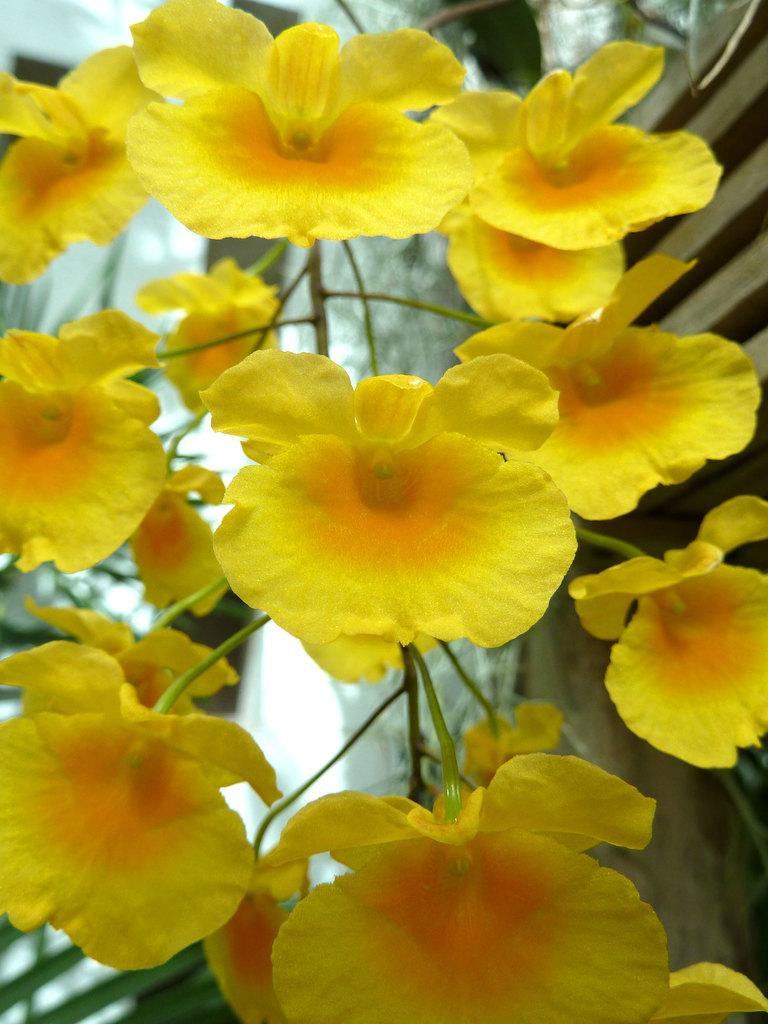What type of flowers can be seen in the image? There are yellow color flowers in the image. What type of ship is visible in the image? There is no ship present in the image; it only features yellow color flowers. What feeling does the image evoke in the viewer? The image does not evoke a specific feeling, as it only contains yellow color flowers and does not convey any emotions or sentiments. 